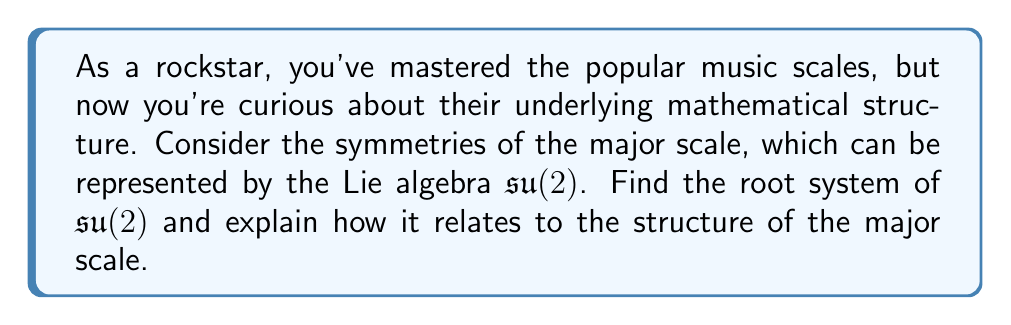Can you answer this question? To find the root system of $\mathfrak{su}(2)$ and relate it to the major scale, we'll follow these steps:

1) The Lie algebra $\mathfrak{su}(2)$ is the set of $2 \times 2$ traceless anti-Hermitian matrices. Its Cartan subalgebra is one-dimensional, spanned by:

   $$H = \begin{pmatrix} i & 0 \\ 0 & -i \end{pmatrix}$$

2) The root system of $\mathfrak{su}(2)$ consists of two roots: $\alpha$ and $-\alpha$. These roots are linear functionals on the Cartan subalgebra.

3) The root vectors corresponding to these roots are:

   $$E_\alpha = \begin{pmatrix} 0 & 1 \\ 0 & 0 \end{pmatrix}, \quad E_{-\alpha} = \begin{pmatrix} 0 & 0 \\ 1 & 0 \end{pmatrix}$$

4) The root system of $\mathfrak{su}(2)$ can be visualized as two points on a line, symmetric about the origin:

   [asy]
   import geometry;
   
   size(200);
   dot("$-\alpha$", (-1,0), W);
   dot("$\alpha$", (1,0), E);
   draw((-1.5,0)--(1.5,0), arrow=Arrow(TeXHead));
   label("0", (0,0), S);
   [/asy]

5) Now, let's relate this to the major scale. The major scale has 7 notes, which can be represented as points on a circle (the circle of fifths). The symmetries of this scale correspond to rotations and reflections of this circle.

6) The two roots $\alpha$ and $-\alpha$ of $\mathfrak{su}(2)$ can be interpreted as the two possible directions of movement along the circle of fifths: clockwise (corresponding to $\alpha$) and counterclockwise (corresponding to $-\alpha$).

7) The Cartan subalgebra element $H$ represents the "rest" state or the tonic of the scale.

8) The root vectors $E_\alpha$ and $E_{-\alpha}$ represent the operations of moving up or down the circle of fifths, respectively.

This mathematical structure captures the essential symmetries of the major scale, demonstrating how abstract algebra can describe musical structures.
Answer: The root system of $\mathfrak{su}(2)$ consists of two roots: $\{\alpha, -\alpha\}$. This system relates to the major scale by representing the two directions of movement along the circle of fifths, capturing the fundamental symmetries of the scale. 